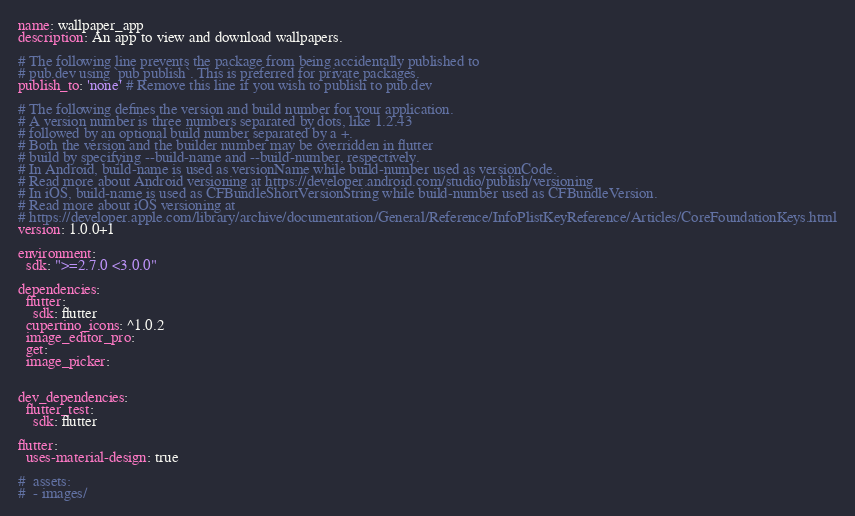<code> <loc_0><loc_0><loc_500><loc_500><_YAML_>name: wallpaper_app
description: An app to view and download wallpapers.

# The following line prevents the package from being accidentally published to
# pub.dev using `pub publish`. This is preferred for private packages.
publish_to: 'none' # Remove this line if you wish to publish to pub.dev

# The following defines the version and build number for your application.
# A version number is three numbers separated by dots, like 1.2.43
# followed by an optional build number separated by a +.
# Both the version and the builder number may be overridden in flutter
# build by specifying --build-name and --build-number, respectively.
# In Android, build-name is used as versionName while build-number used as versionCode.
# Read more about Android versioning at https://developer.android.com/studio/publish/versioning
# In iOS, build-name is used as CFBundleShortVersionString while build-number used as CFBundleVersion.
# Read more about iOS versioning at
# https://developer.apple.com/library/archive/documentation/General/Reference/InfoPlistKeyReference/Articles/CoreFoundationKeys.html
version: 1.0.0+1

environment:
  sdk: ">=2.7.0 <3.0.0"

dependencies:
  flutter:
    sdk: flutter
  cupertino_icons: ^1.0.2
  image_editor_pro:
  get:
  image_picker:


dev_dependencies:
  flutter_test:
    sdk: flutter

flutter:
  uses-material-design: true

#  assets:
#  - images/</code> 